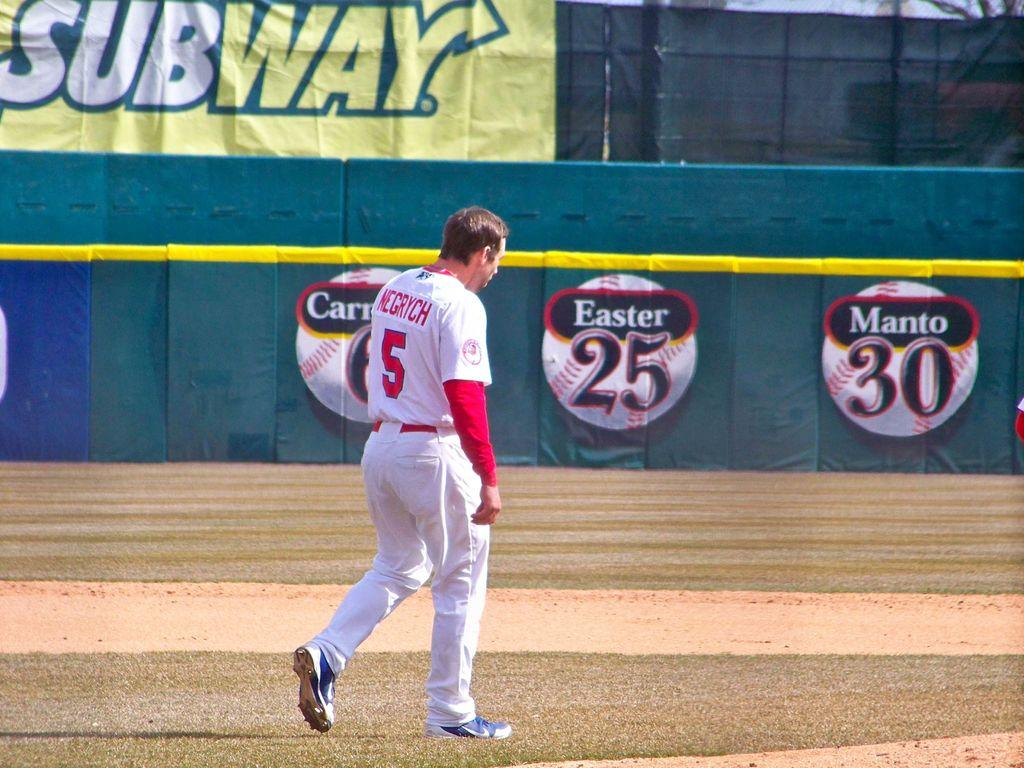<image>
Relay a brief, clear account of the picture shown. A man wearing the jersey number 5 with the name Negrych walks in front of an ad for Subway. 